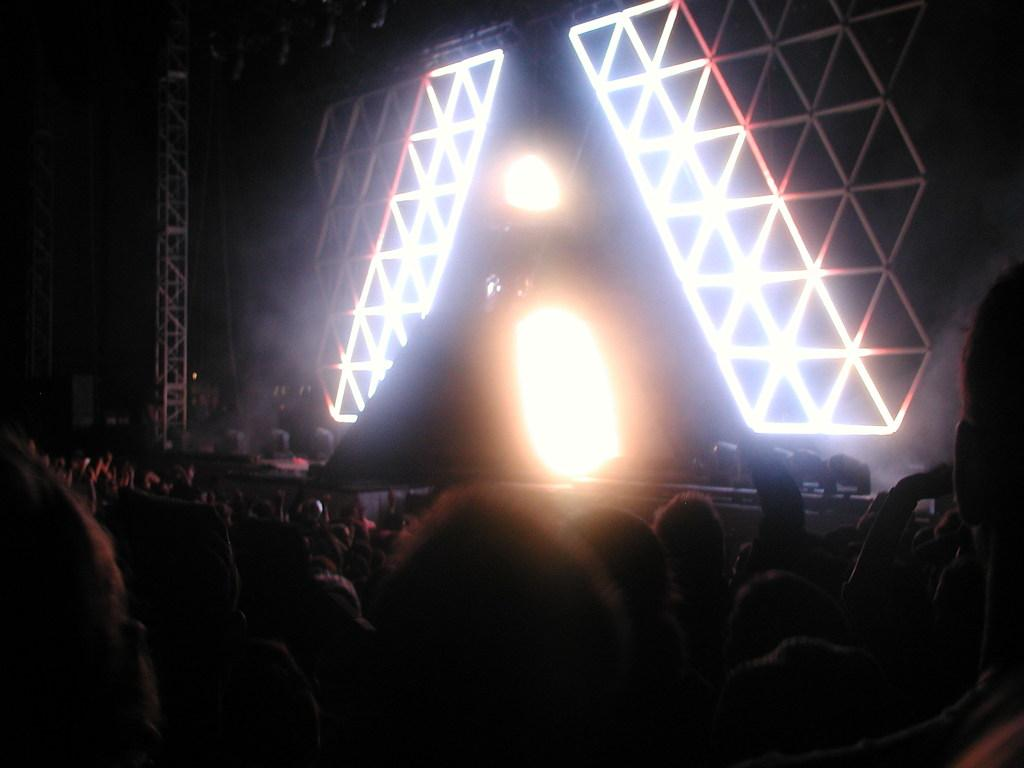How many people are in the image? There is a group of people in the image. What is the main feature of the image? There is a stage in the image. What can be seen on the stage? Lights and metal rods are visible on the stage. What is the color of the background in the image? The background of the image is black. How many jellyfish are swimming in the background of the image? There are no jellyfish present in the image; the background is black. What type of music is being played by the people on the stage? The image does not provide any information about the type of music being played, as it only shows the stage and its features. 